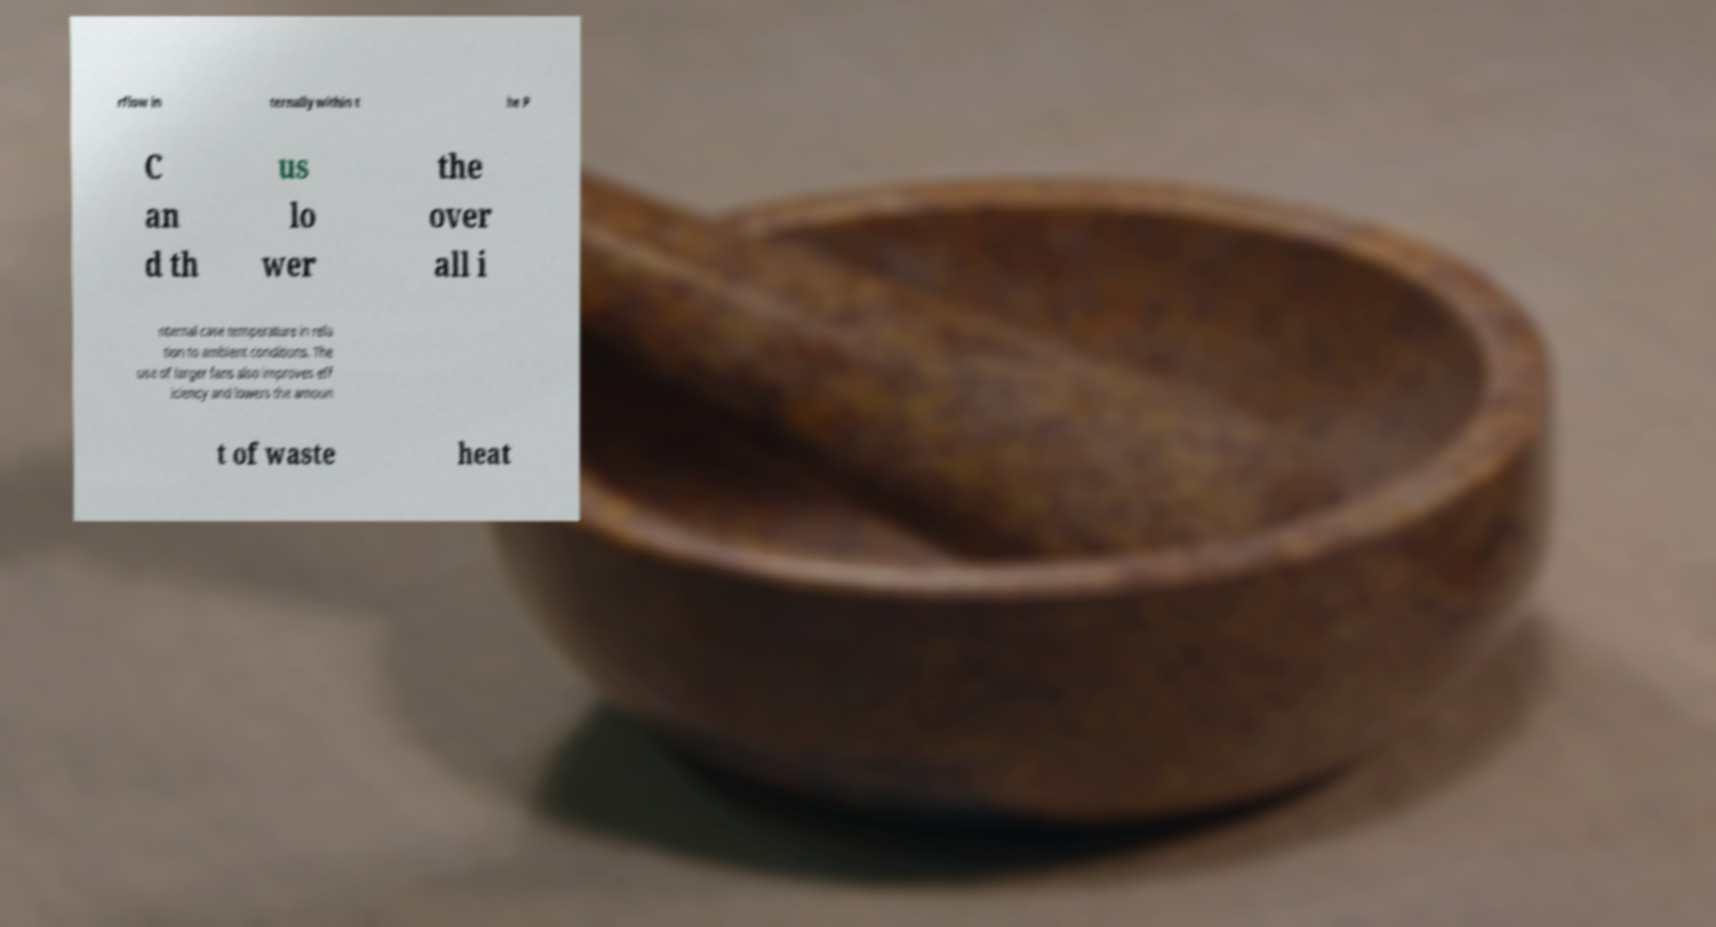What messages or text are displayed in this image? I need them in a readable, typed format. rflow in ternally within t he P C an d th us lo wer the over all i nternal case temperature in rela tion to ambient conditions. The use of larger fans also improves eff iciency and lowers the amoun t of waste heat 